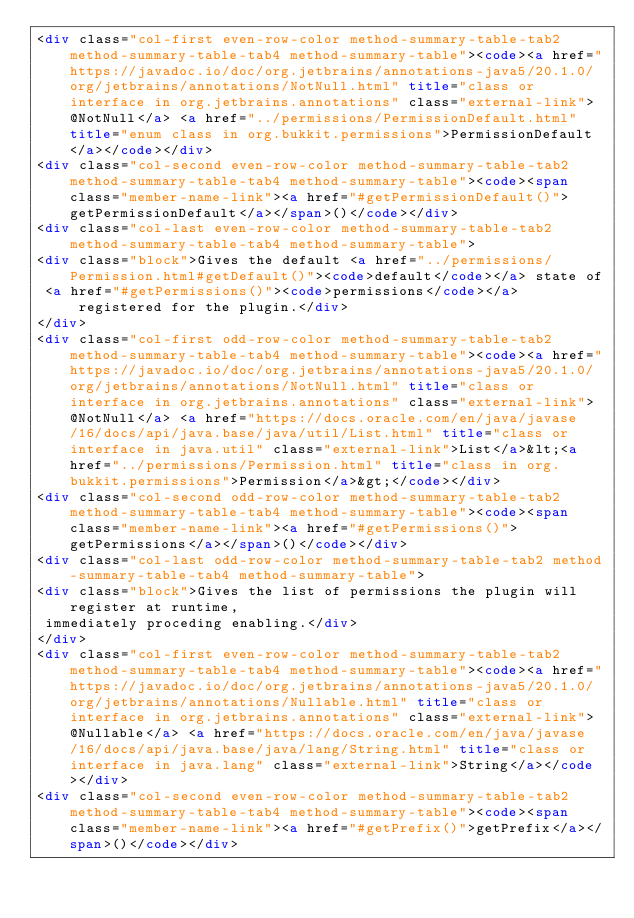Convert code to text. <code><loc_0><loc_0><loc_500><loc_500><_HTML_><div class="col-first even-row-color method-summary-table-tab2 method-summary-table-tab4 method-summary-table"><code><a href="https://javadoc.io/doc/org.jetbrains/annotations-java5/20.1.0/org/jetbrains/annotations/NotNull.html" title="class or interface in org.jetbrains.annotations" class="external-link">@NotNull</a> <a href="../permissions/PermissionDefault.html" title="enum class in org.bukkit.permissions">PermissionDefault</a></code></div>
<div class="col-second even-row-color method-summary-table-tab2 method-summary-table-tab4 method-summary-table"><code><span class="member-name-link"><a href="#getPermissionDefault()">getPermissionDefault</a></span>()</code></div>
<div class="col-last even-row-color method-summary-table-tab2 method-summary-table-tab4 method-summary-table">
<div class="block">Gives the default <a href="../permissions/Permission.html#getDefault()"><code>default</code></a> state of
 <a href="#getPermissions()"><code>permissions</code></a> registered for the plugin.</div>
</div>
<div class="col-first odd-row-color method-summary-table-tab2 method-summary-table-tab4 method-summary-table"><code><a href="https://javadoc.io/doc/org.jetbrains/annotations-java5/20.1.0/org/jetbrains/annotations/NotNull.html" title="class or interface in org.jetbrains.annotations" class="external-link">@NotNull</a> <a href="https://docs.oracle.com/en/java/javase/16/docs/api/java.base/java/util/List.html" title="class or interface in java.util" class="external-link">List</a>&lt;<a href="../permissions/Permission.html" title="class in org.bukkit.permissions">Permission</a>&gt;</code></div>
<div class="col-second odd-row-color method-summary-table-tab2 method-summary-table-tab4 method-summary-table"><code><span class="member-name-link"><a href="#getPermissions()">getPermissions</a></span>()</code></div>
<div class="col-last odd-row-color method-summary-table-tab2 method-summary-table-tab4 method-summary-table">
<div class="block">Gives the list of permissions the plugin will register at runtime,
 immediately proceding enabling.</div>
</div>
<div class="col-first even-row-color method-summary-table-tab2 method-summary-table-tab4 method-summary-table"><code><a href="https://javadoc.io/doc/org.jetbrains/annotations-java5/20.1.0/org/jetbrains/annotations/Nullable.html" title="class or interface in org.jetbrains.annotations" class="external-link">@Nullable</a> <a href="https://docs.oracle.com/en/java/javase/16/docs/api/java.base/java/lang/String.html" title="class or interface in java.lang" class="external-link">String</a></code></div>
<div class="col-second even-row-color method-summary-table-tab2 method-summary-table-tab4 method-summary-table"><code><span class="member-name-link"><a href="#getPrefix()">getPrefix</a></span>()</code></div></code> 